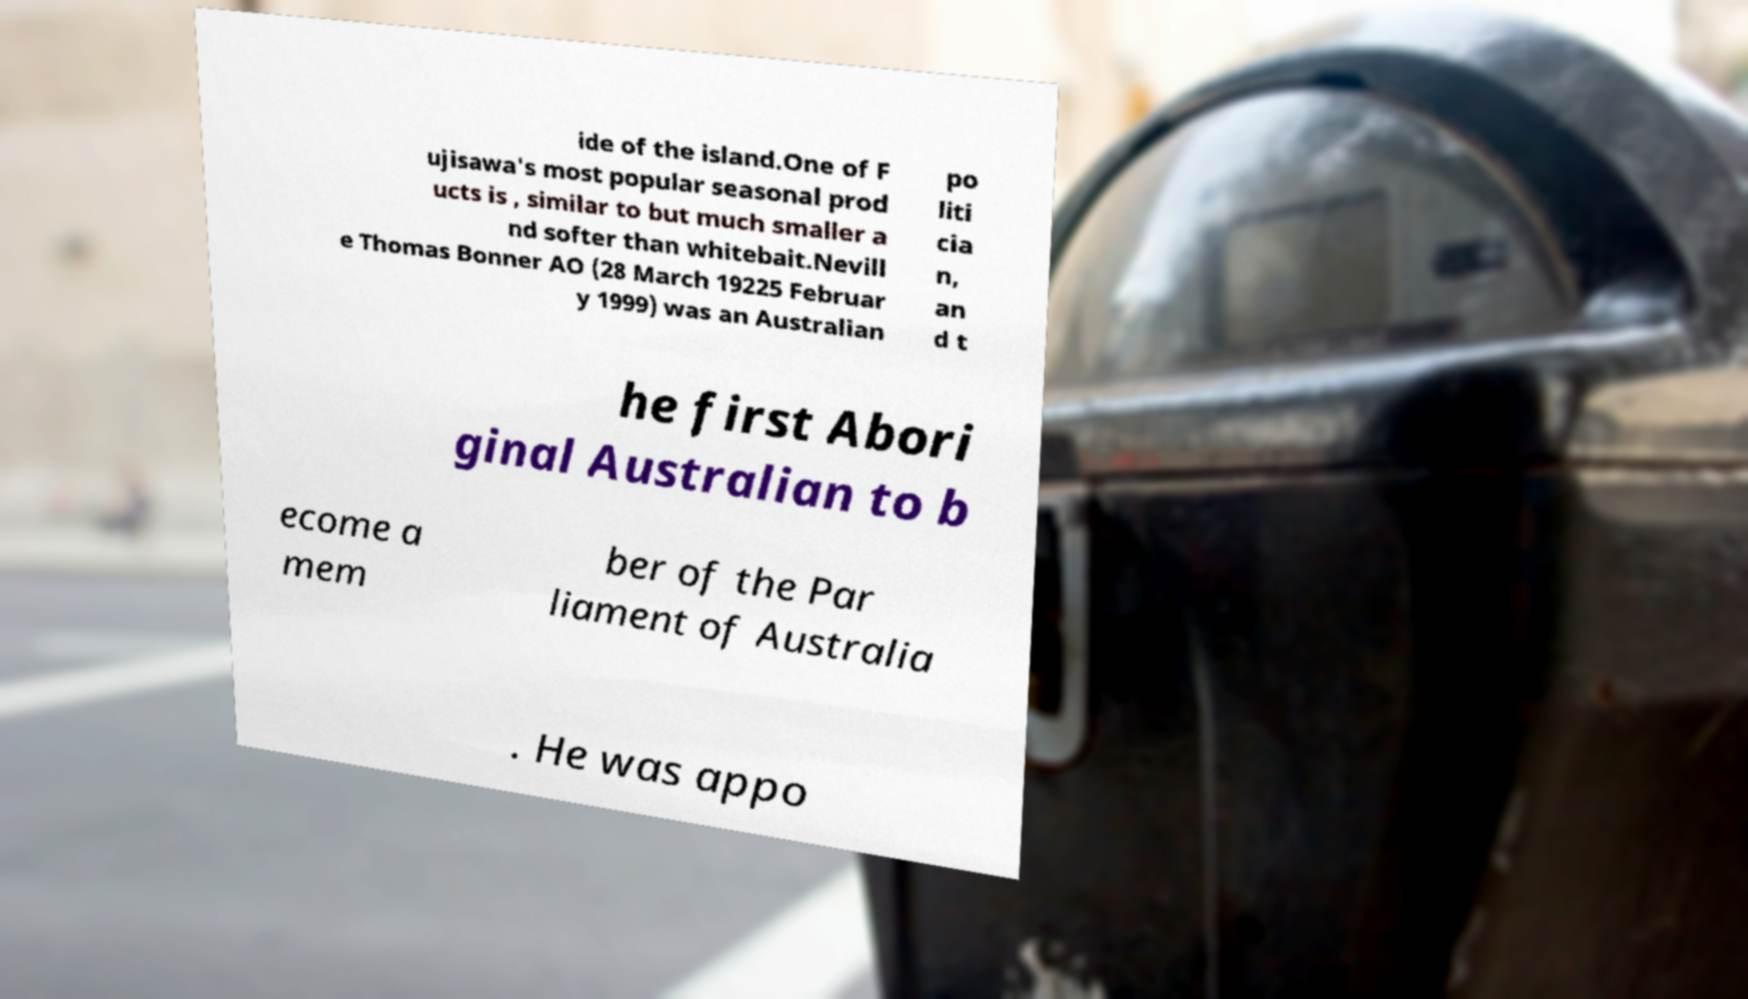What messages or text are displayed in this image? I need them in a readable, typed format. ide of the island.One of F ujisawa's most popular seasonal prod ucts is , similar to but much smaller a nd softer than whitebait.Nevill e Thomas Bonner AO (28 March 19225 Februar y 1999) was an Australian po liti cia n, an d t he first Abori ginal Australian to b ecome a mem ber of the Par liament of Australia . He was appo 